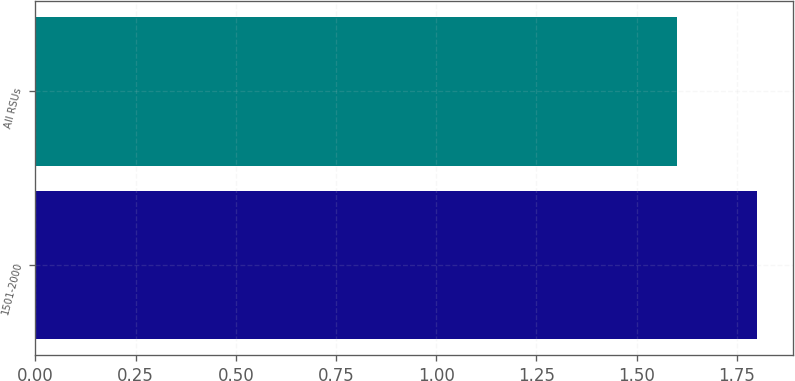<chart> <loc_0><loc_0><loc_500><loc_500><bar_chart><fcel>1501-2000<fcel>All RSUs<nl><fcel>1.8<fcel>1.6<nl></chart> 